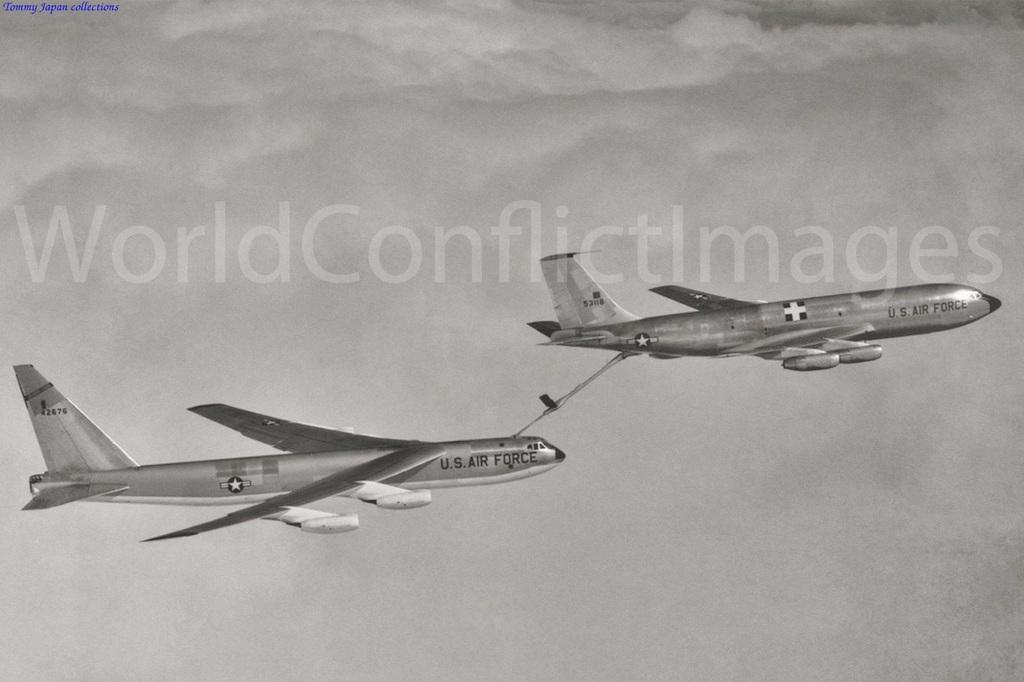What is the main subject of the image? The main subject of the image is aeroplanes. What are the aeroplanes doing in the image? The aeroplanes are flying in the sky. Can you see any milk being poured in the image? There is no milk being poured in the image; it features aeroplanes flying in the sky. Is there a house visible in the image? There is no house visible in the image; it only features aeroplanes flying in the sky. 